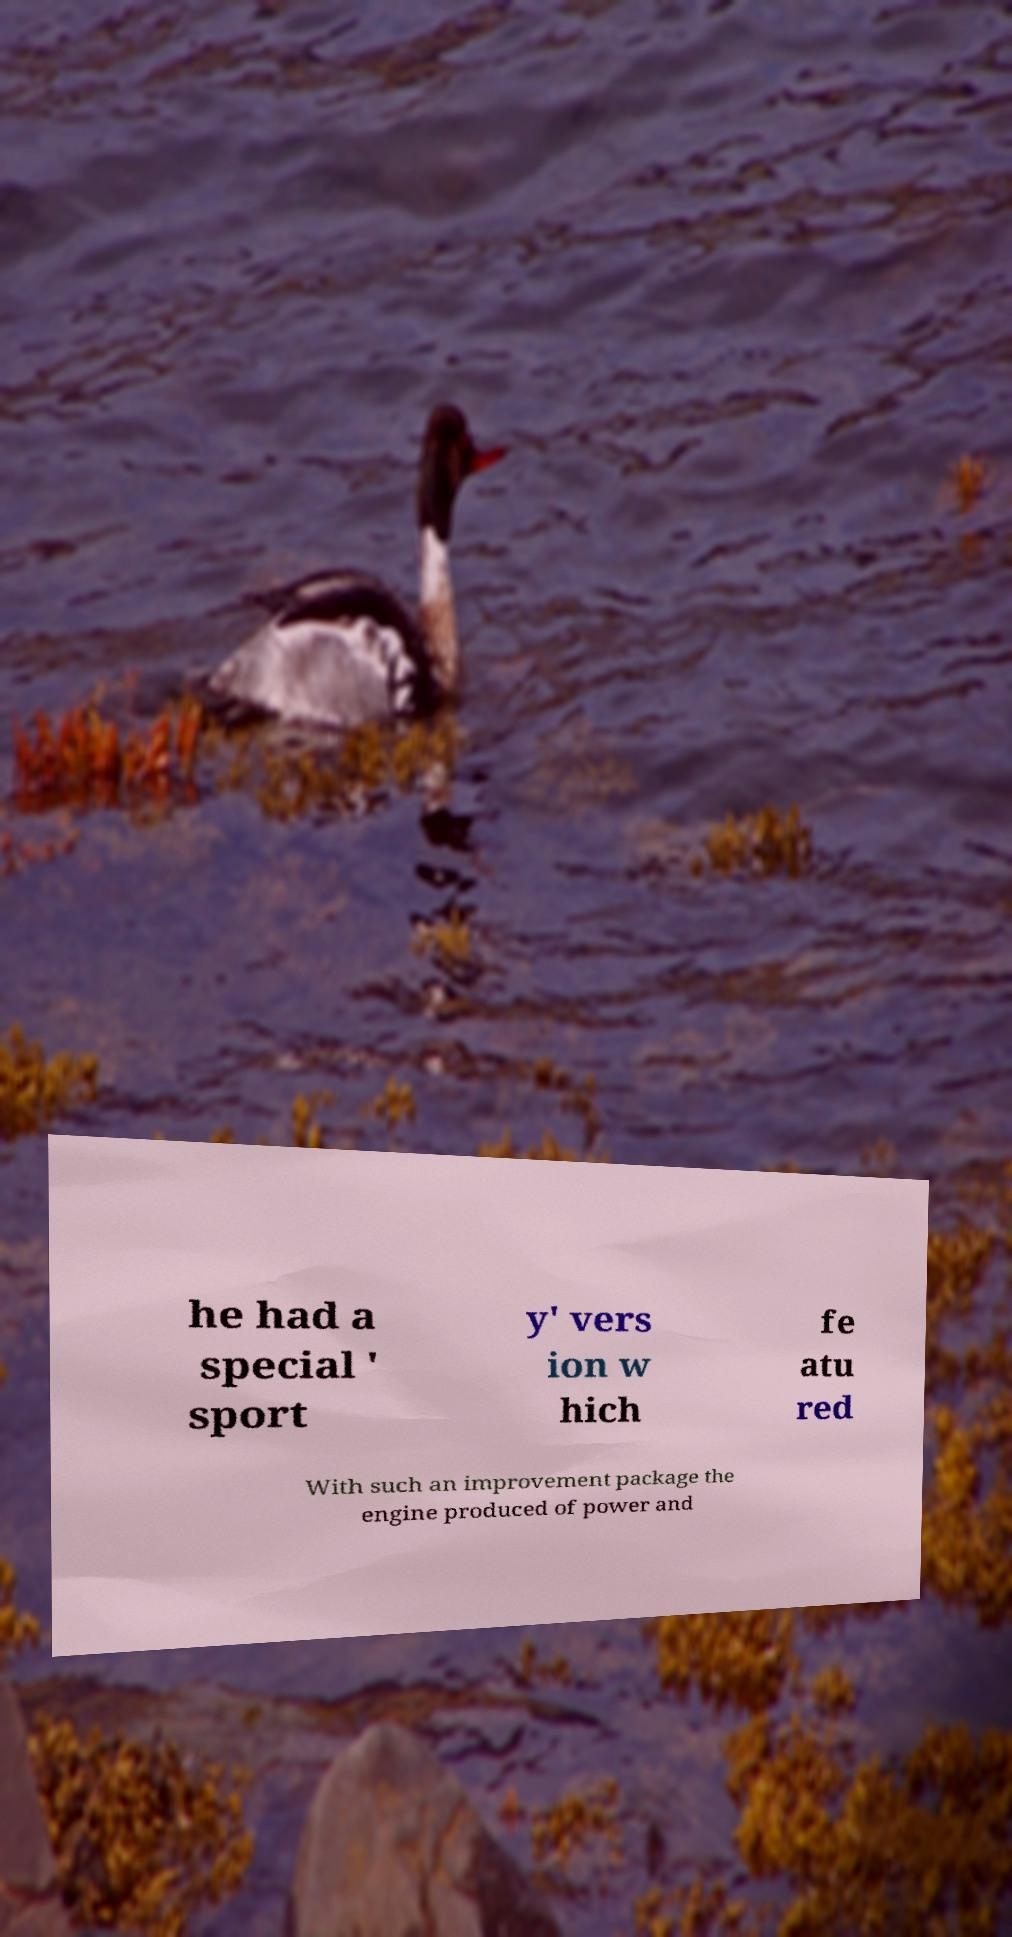Can you accurately transcribe the text from the provided image for me? he had a special ' sport y' vers ion w hich fe atu red With such an improvement package the engine produced of power and 